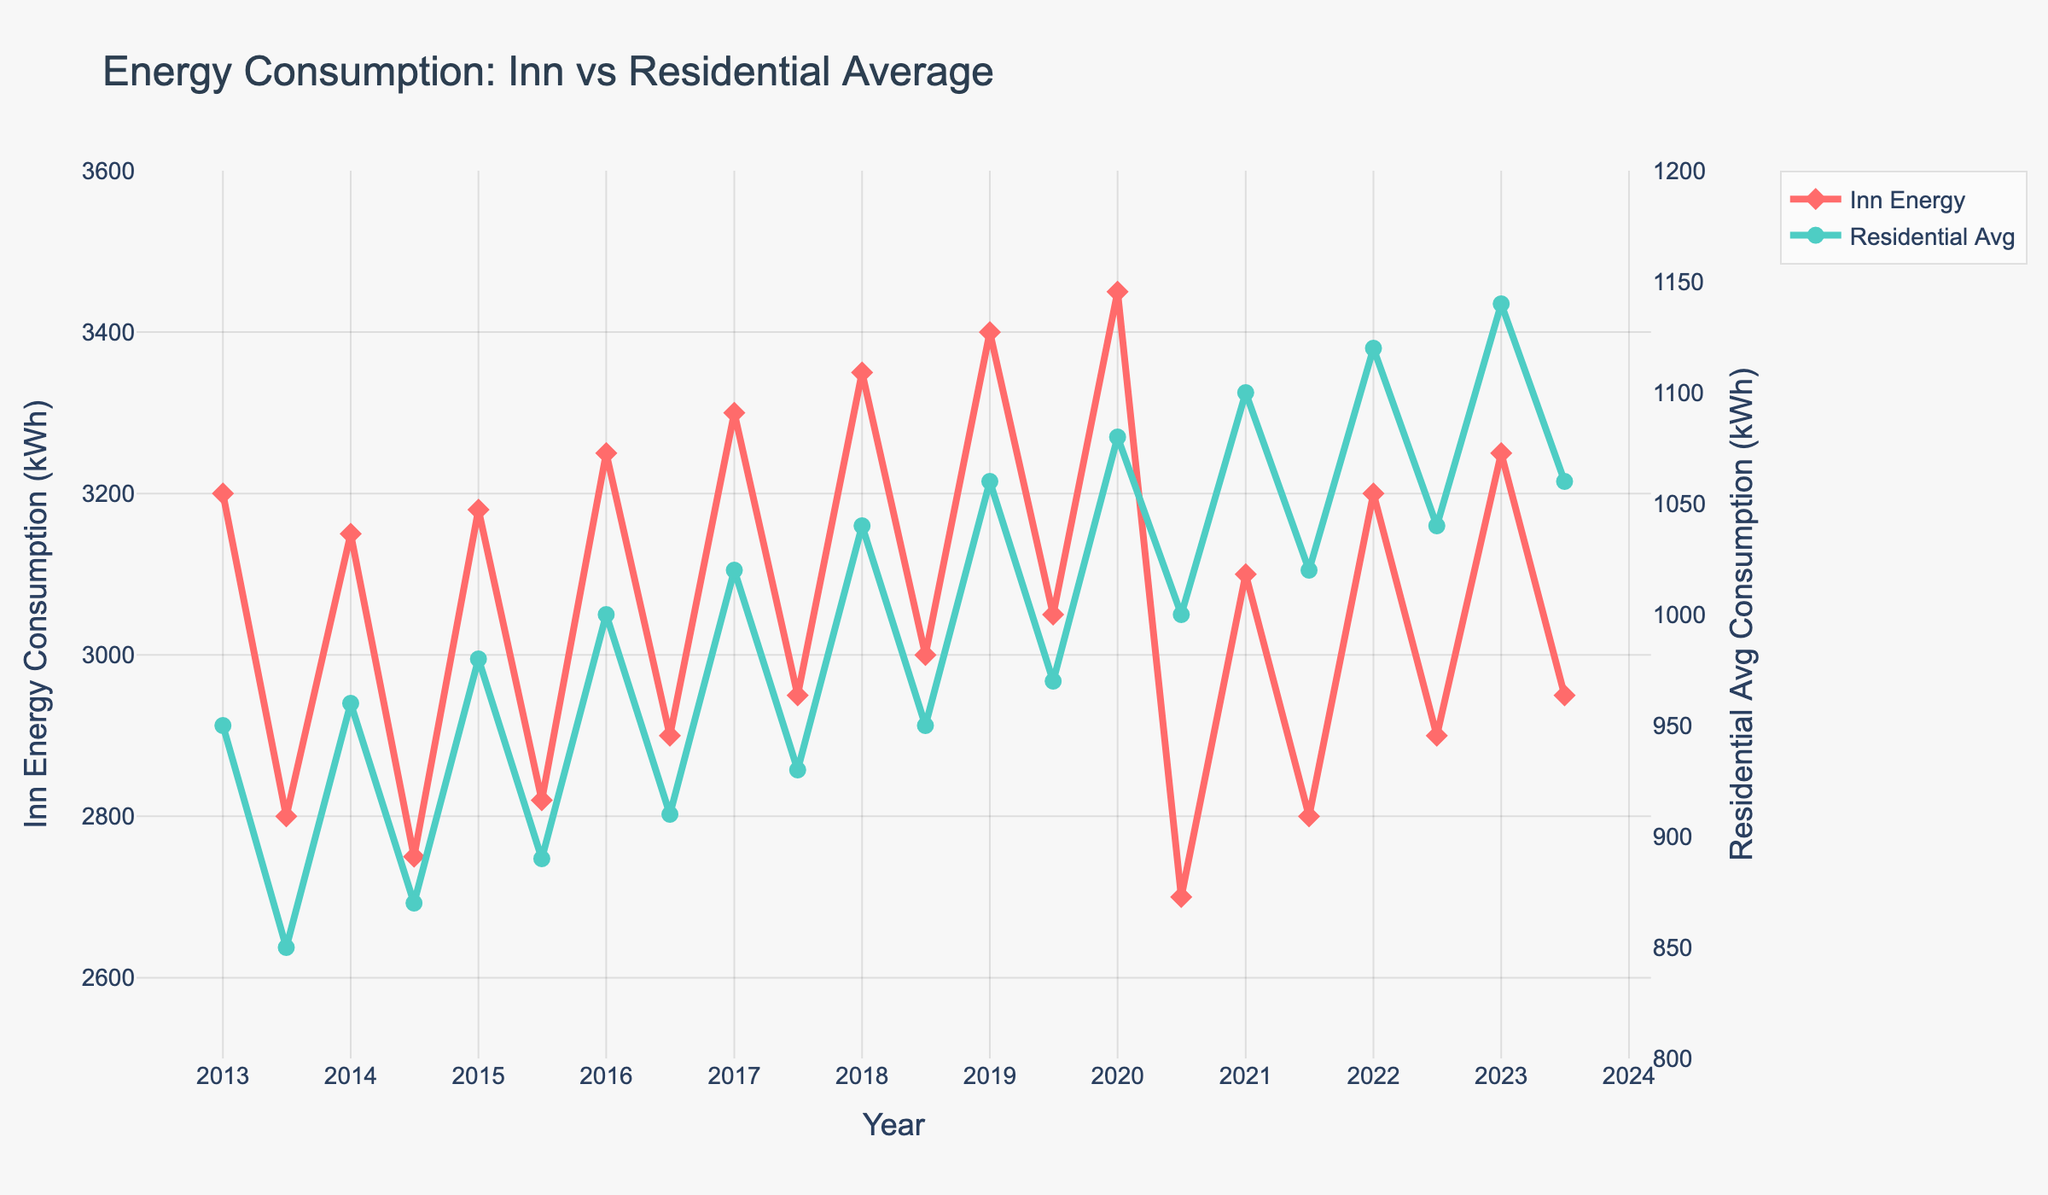How does the inn's energy consumption in January 2023 compare to July 2023? The line chart shows the inn's energy consumption in January 2023 and July 2023. By looking at the respective data points, January 2023 has an energy consumption of 3250 kWh, while July 2023 has a consumption of 2950 kWh.
Answer: 3250 kWh vs 2950 kWh What is the difference in the average residential energy consumption between January 2013 and January 2023? The chart provides the residential energy consumption in January 2013 and January 2023. In January 2013, it is 950 kWh and in January 2023, it is 1140 kWh. The difference is calculated as 1140 kWh - 950 kWh.
Answer: 190 kWh During which year did the inn's energy consumption in July see the steepest decline compared to the previous year? To find this, compare the energy consumption in July for each year with the previous year. The inn's energy consumption in July 2020 was 2700 kWh, down from 3050 kWh in July 2019, representing the steepest decline.
Answer: 2020 On average, is the inn's energy consumption higher in January or July over the decade? Calculate the average energy consumption for January and July over the ten-year period. Summing January's values and dividing by 11 gives an average of approximately 3236.36 kWh, while summing July's values and dividing by 11 gives an average of approximately 2862.73 kWh. Therefore, January has higher average consumption.
Answer: January How do the visual markers for the inn's energy consumption compare to the residential average? The line chart uses diamond markers for the inn's energy consumption whereas the residential average uses circle markers.
Answer: Diamond vs Circle Which year shows the smallest difference between the inn's energy consumption in January and July? By examining the chart, calculate the difference for each year. In 2013, the difference is 3200 kWh - 2800 kWh = 400 kWh. Continue this for each year; 2021 shows the smallest difference with 3100 kWh - 2800 kWh = 300 kWh.
Answer: 2021 In what year does the residential average energy consumption exceed 1000 kWh for the first time? Check the historical residential energy consumption data points. The first occurrence where it exceeds 1000 kWh is in January 2016.
Answer: 2016 By how much did the inn's energy consumption decrease from January 2019 to January 2021? The inn's energy consumption in January 2019 was 3400 kWh and in January 2021 was 3100 kWh. The decrease is calculated as 3400 kWh - 3100 kWh.
Answer: 300 kWh How does the trend of the inn's energy consumption compare to the residential average over the decade? By observing the chart, the inn's energy consumption is relatively high in January compared to July, showing a consistent pattern. In contrast, the residential average shows a gradual increase over the years, particularly during the colder months (January).
Answer: Inn shows consistent pattern, Residential increases 